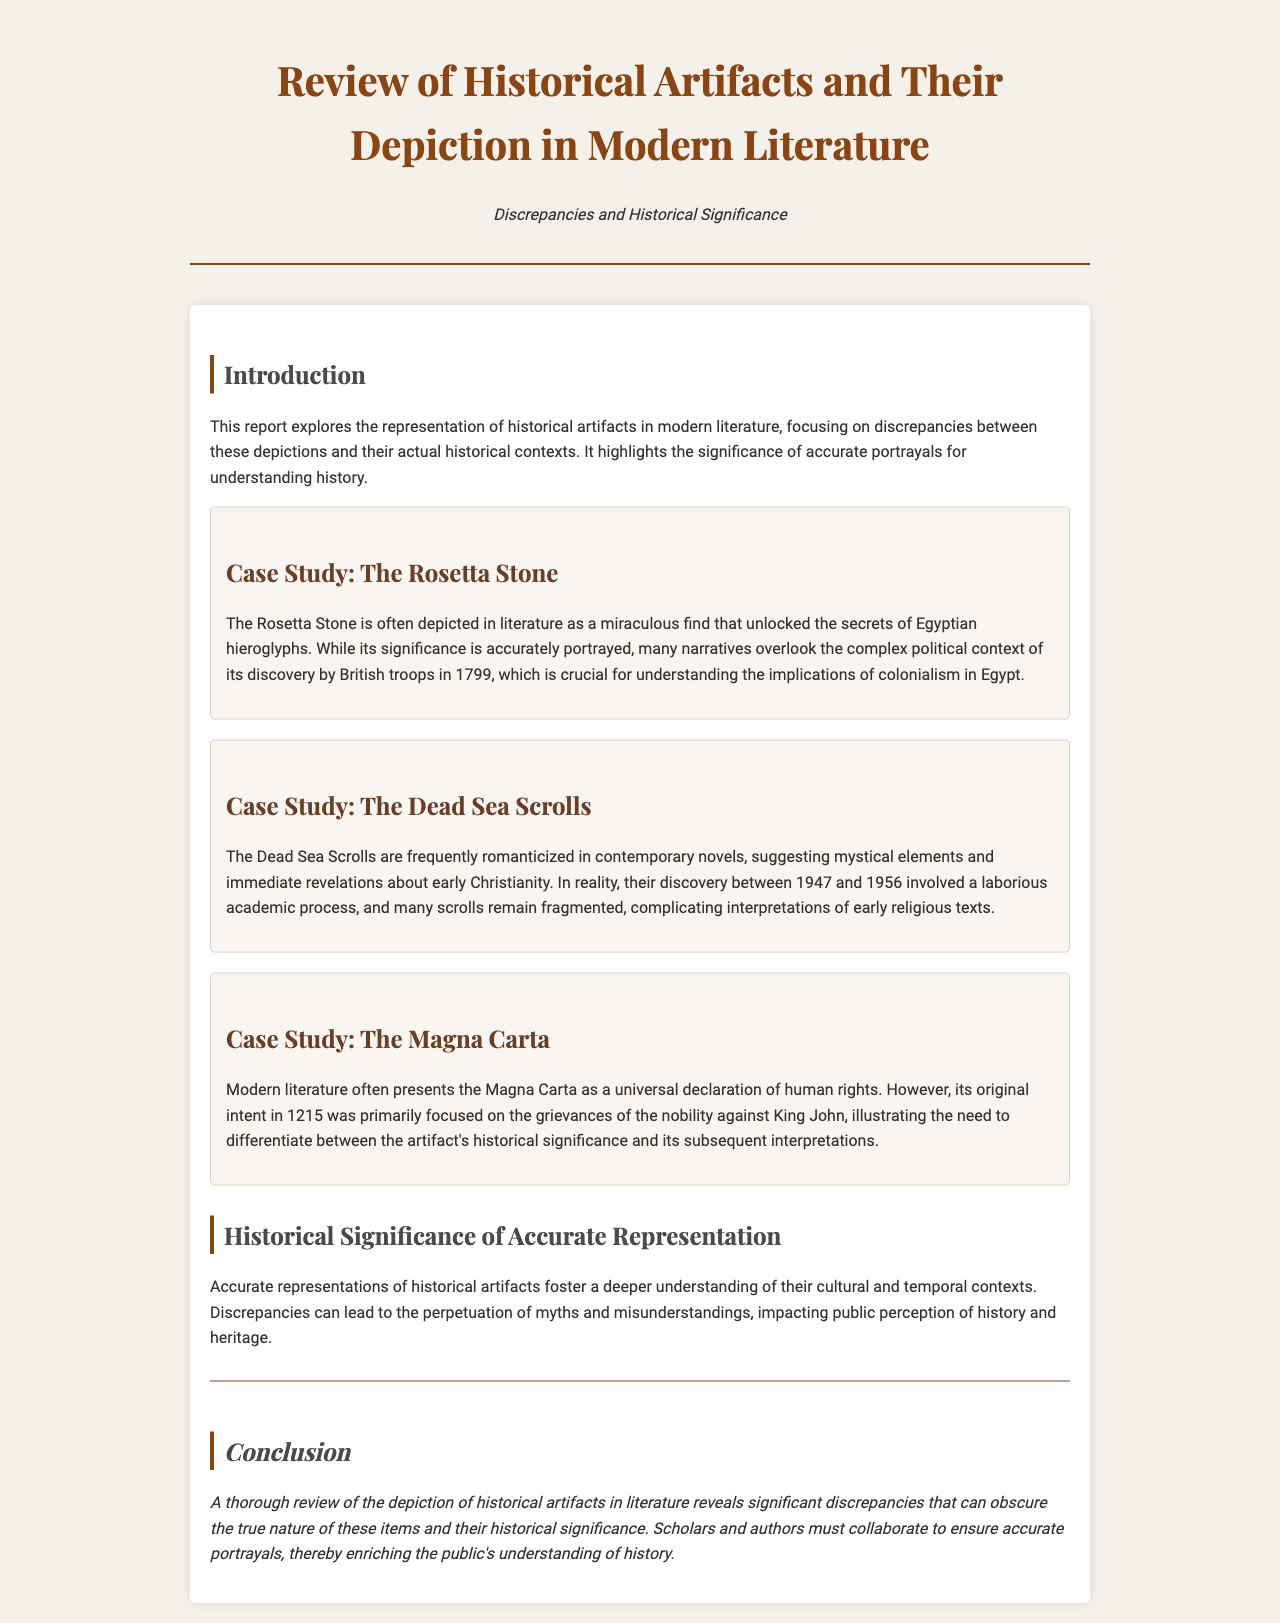What is the title of the report? The title of the report provides the focus of the document.
Answer: Review of Historical Artifacts and Their Depiction in Modern Literature What year was the Rosetta Stone discovered? The report mentions the discovery context of the Rosetta Stone, which is relevant to its historical significance.
Answer: 1799 What is highlighted in the case study of the Dead Sea Scrolls? The case study emphasizes the nature of the discovery and its implications for understanding early texts.
Answer: Romanticized elements What was the primary focus of the Magna Carta when it was created? The report discusses the original intent of the Magna Carta, comparing past and present interpretations.
Answer: Grievances of the nobility Why is accurate representation of historical artifacts important? The document explains the significance of accurate representations in understanding cultural contexts.
Answer: Deeper understanding How many years did the discovery of the Dead Sea Scrolls span? The report states the years involved in the discovery of the Dead Sea Scrolls, which illustrates the complexity of its context.
Answer: Nine years What genre of literature often romanticizes the Dead Sea Scrolls? The report describes the style of literature that tends to depict historical artifacts in a particular light.
Answer: Contemporary novels What does the report suggest scholars and authors must do? The conclusion of the report makes a recommendation regarding collaboration for better historical understanding.
Answer: Collaborate to ensure accurate portrayals 